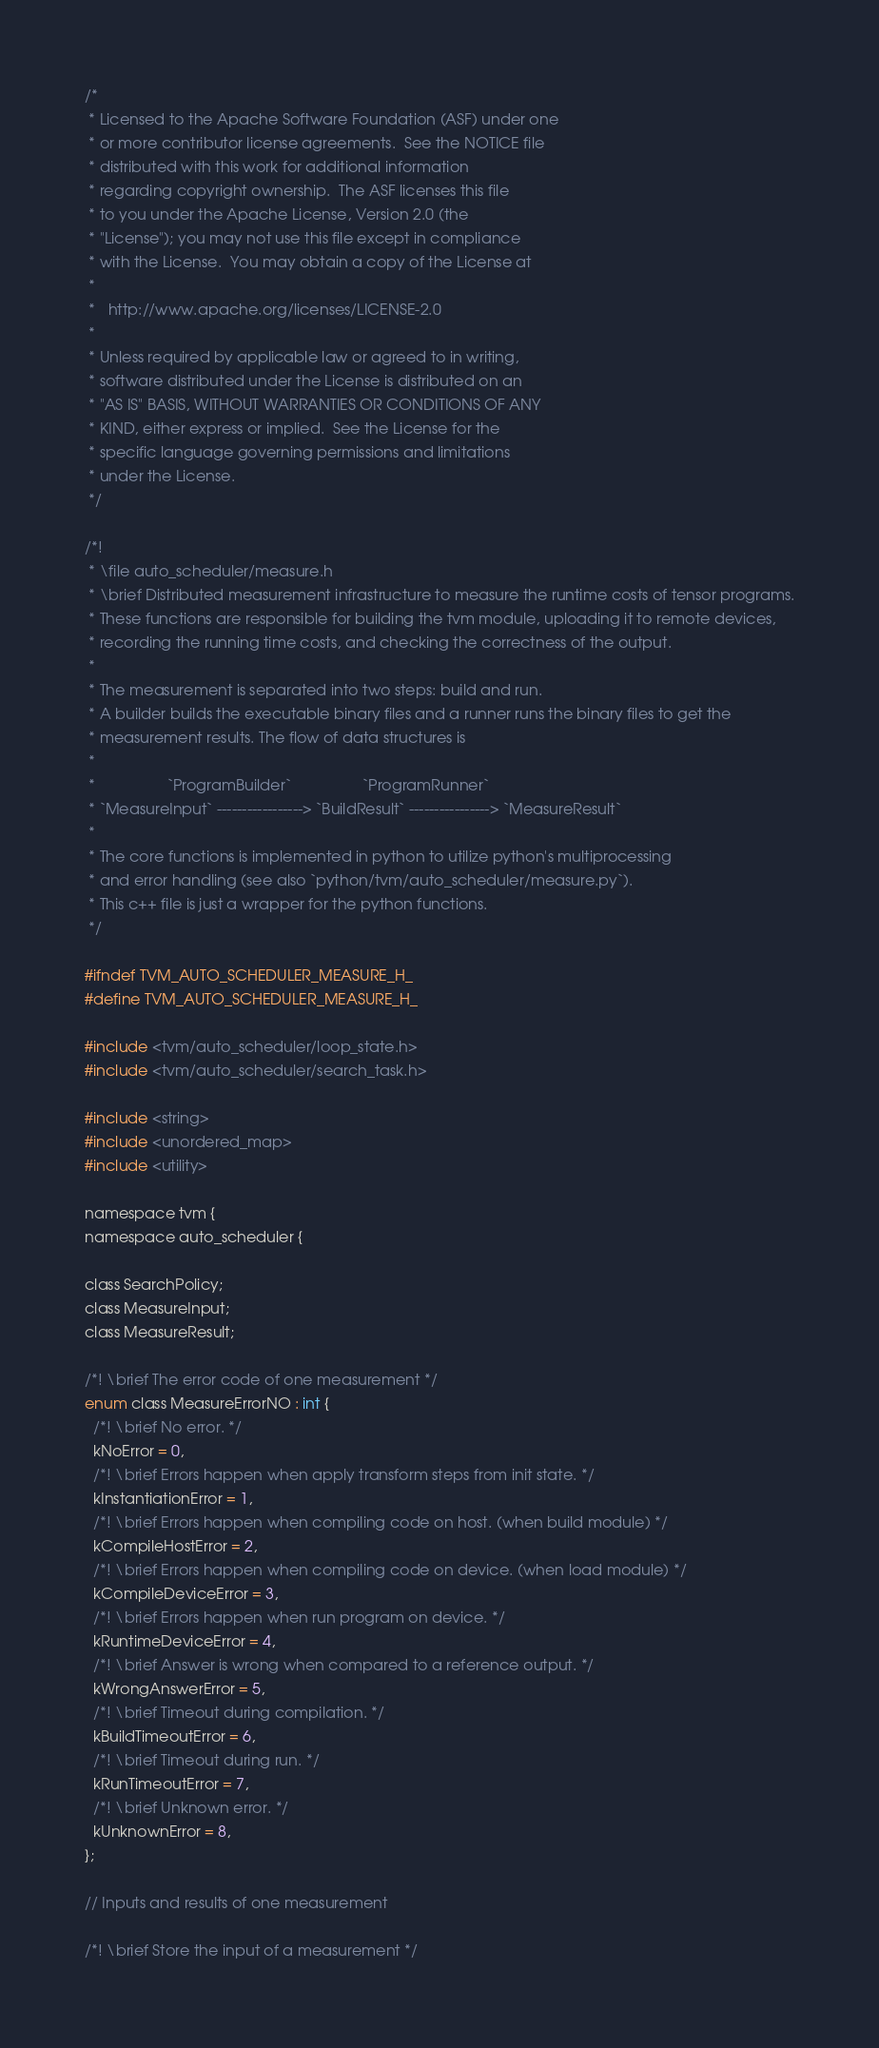<code> <loc_0><loc_0><loc_500><loc_500><_C_>/*
 * Licensed to the Apache Software Foundation (ASF) under one
 * or more contributor license agreements.  See the NOTICE file
 * distributed with this work for additional information
 * regarding copyright ownership.  The ASF licenses this file
 * to you under the Apache License, Version 2.0 (the
 * "License"); you may not use this file except in compliance
 * with the License.  You may obtain a copy of the License at
 *
 *   http://www.apache.org/licenses/LICENSE-2.0
 *
 * Unless required by applicable law or agreed to in writing,
 * software distributed under the License is distributed on an
 * "AS IS" BASIS, WITHOUT WARRANTIES OR CONDITIONS OF ANY
 * KIND, either express or implied.  See the License for the
 * specific language governing permissions and limitations
 * under the License.
 */

/*!
 * \file auto_scheduler/measure.h
 * \brief Distributed measurement infrastructure to measure the runtime costs of tensor programs.
 * These functions are responsible for building the tvm module, uploading it to remote devices,
 * recording the running time costs, and checking the correctness of the output.
 *
 * The measurement is separated into two steps: build and run.
 * A builder builds the executable binary files and a runner runs the binary files to get the
 * measurement results. The flow of data structures is
 *
 *                 `ProgramBuilder`                 `ProgramRunner`
 * `MeasureInput` -----------------> `BuildResult` ----------------> `MeasureResult`
 *
 * The core functions is implemented in python to utilize python's multiprocessing
 * and error handling (see also `python/tvm/auto_scheduler/measure.py`).
 * This c++ file is just a wrapper for the python functions.
 */

#ifndef TVM_AUTO_SCHEDULER_MEASURE_H_
#define TVM_AUTO_SCHEDULER_MEASURE_H_

#include <tvm/auto_scheduler/loop_state.h>
#include <tvm/auto_scheduler/search_task.h>

#include <string>
#include <unordered_map>
#include <utility>

namespace tvm {
namespace auto_scheduler {

class SearchPolicy;
class MeasureInput;
class MeasureResult;

/*! \brief The error code of one measurement */
enum class MeasureErrorNO : int {
  /*! \brief No error. */
  kNoError = 0,
  /*! \brief Errors happen when apply transform steps from init state. */
  kInstantiationError = 1,
  /*! \brief Errors happen when compiling code on host. (when build module) */
  kCompileHostError = 2,
  /*! \brief Errors happen when compiling code on device. (when load module) */
  kCompileDeviceError = 3,
  /*! \brief Errors happen when run program on device. */
  kRuntimeDeviceError = 4,
  /*! \brief Answer is wrong when compared to a reference output. */
  kWrongAnswerError = 5,
  /*! \brief Timeout during compilation. */
  kBuildTimeoutError = 6,
  /*! \brief Timeout during run. */
  kRunTimeoutError = 7,
  /*! \brief Unknown error. */
  kUnknownError = 8,
};

// Inputs and results of one measurement

/*! \brief Store the input of a measurement */</code> 